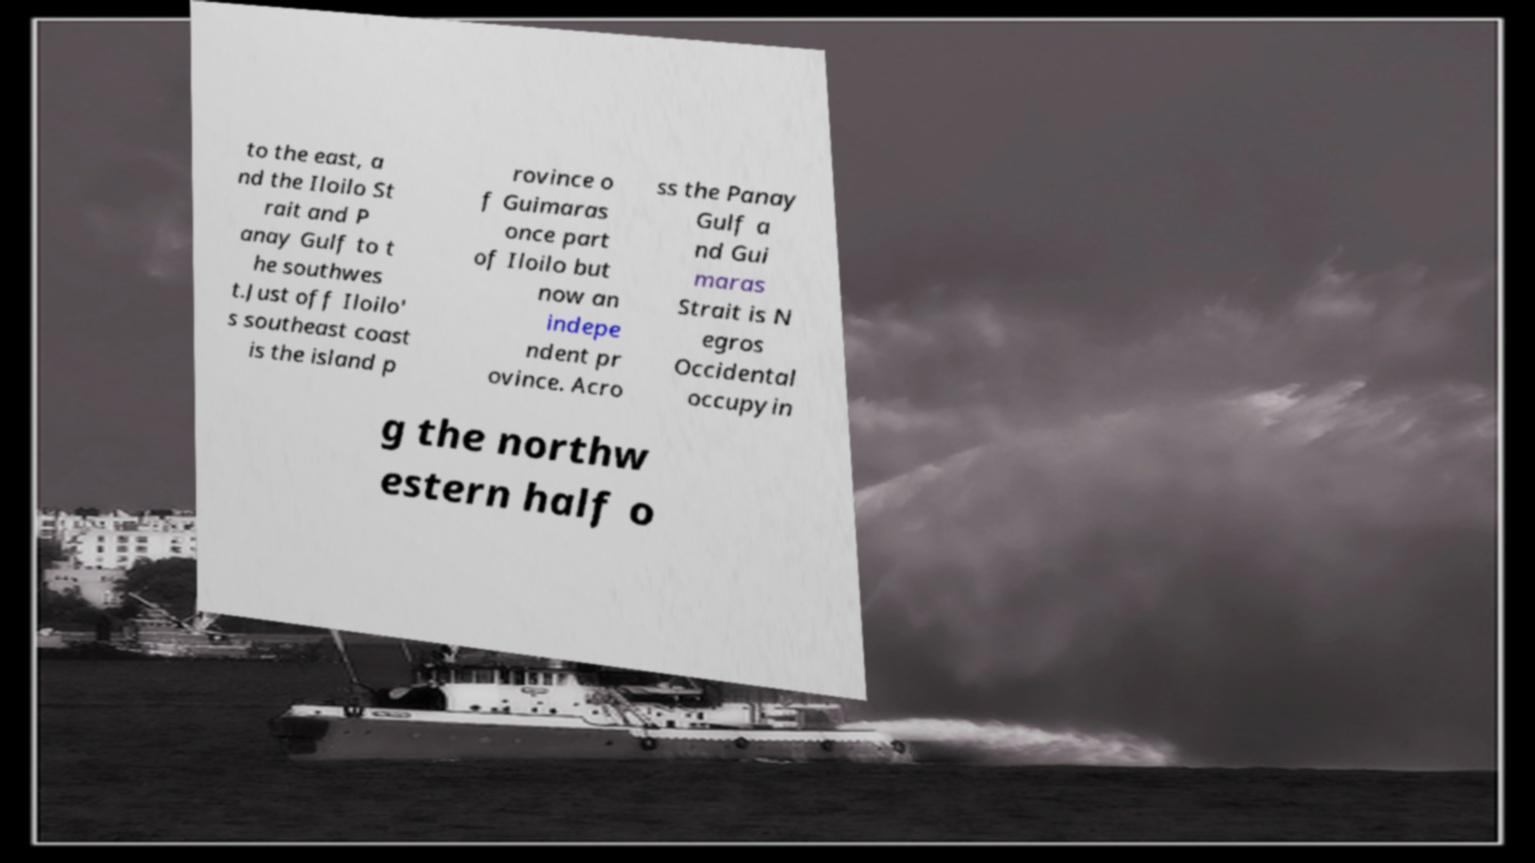Could you extract and type out the text from this image? to the east, a nd the Iloilo St rait and P anay Gulf to t he southwes t.Just off Iloilo' s southeast coast is the island p rovince o f Guimaras once part of Iloilo but now an indepe ndent pr ovince. Acro ss the Panay Gulf a nd Gui maras Strait is N egros Occidental occupyin g the northw estern half o 